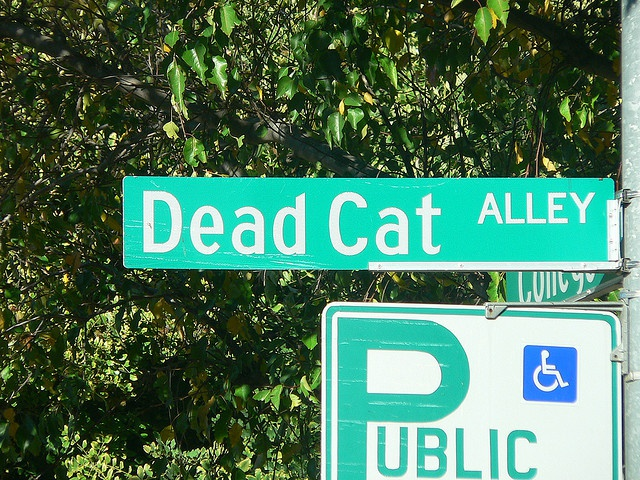Describe the objects in this image and their specific colors. I can see various objects in this image with different colors. 